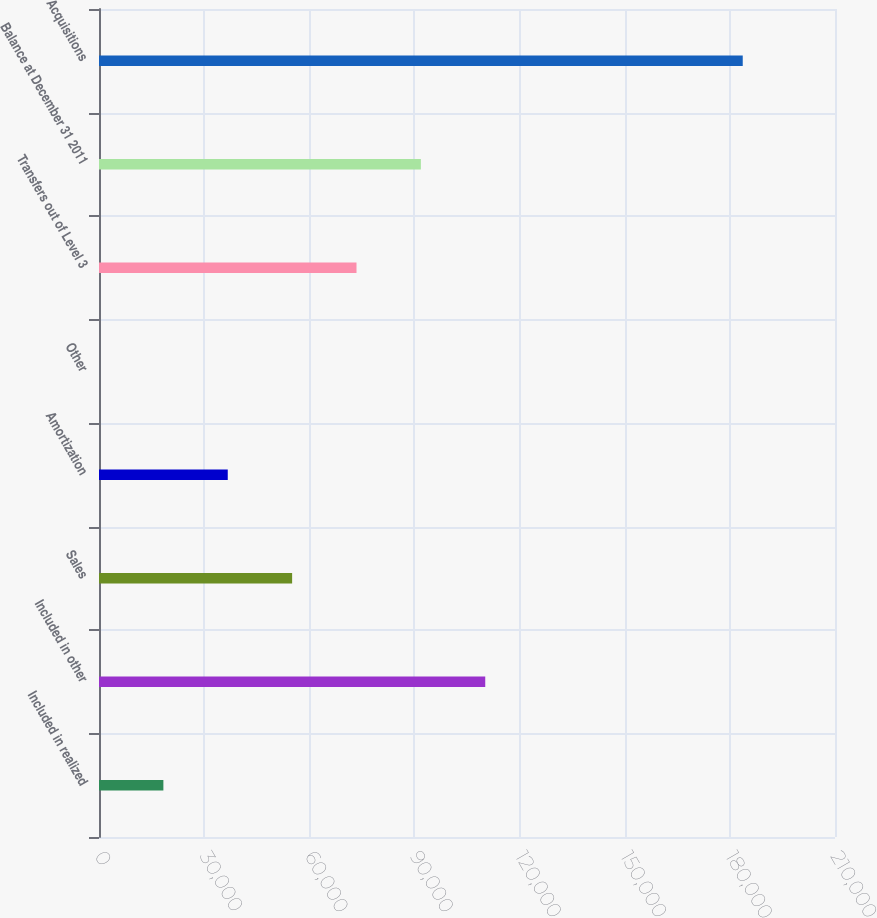Convert chart. <chart><loc_0><loc_0><loc_500><loc_500><bar_chart><fcel>Included in realized<fcel>Included in other<fcel>Sales<fcel>Amortization<fcel>Other<fcel>Transfers out of Level 3<fcel>Balance at December 31 2011<fcel>Acquisitions<nl><fcel>18369.8<fcel>110207<fcel>55104.5<fcel>36737.1<fcel>2.39<fcel>73471.8<fcel>91839.2<fcel>183676<nl></chart> 